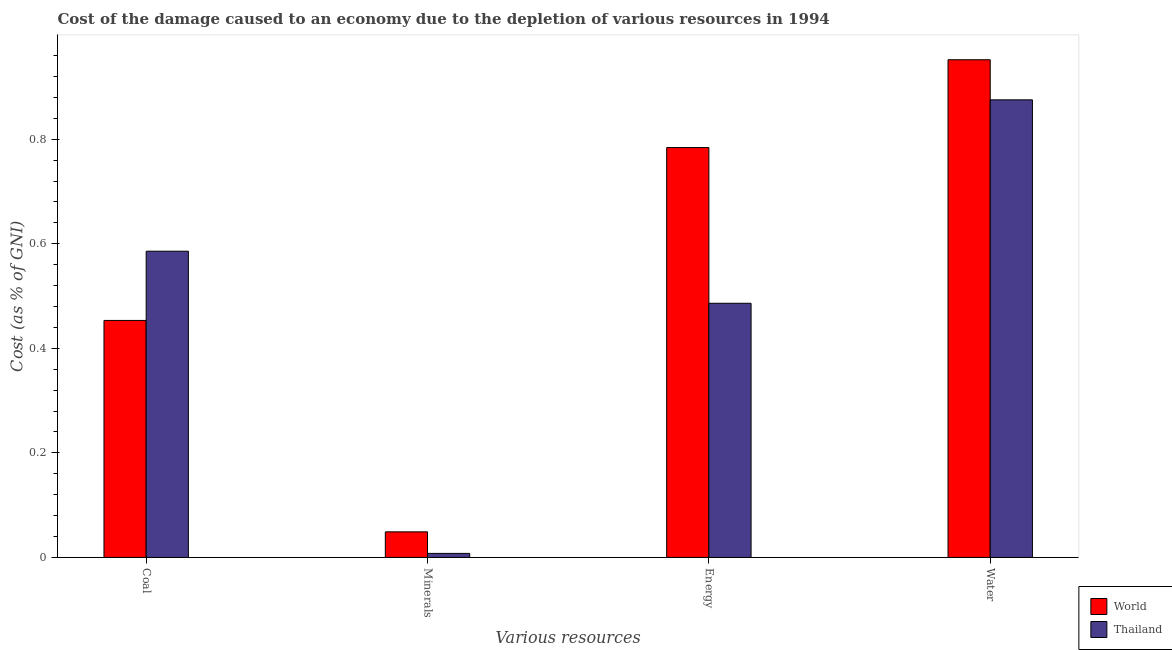How many different coloured bars are there?
Your response must be concise. 2. Are the number of bars per tick equal to the number of legend labels?
Offer a terse response. Yes. Are the number of bars on each tick of the X-axis equal?
Your response must be concise. Yes. What is the label of the 1st group of bars from the left?
Provide a short and direct response. Coal. What is the cost of damage due to depletion of coal in World?
Make the answer very short. 0.45. Across all countries, what is the maximum cost of damage due to depletion of minerals?
Offer a terse response. 0.05. Across all countries, what is the minimum cost of damage due to depletion of minerals?
Your answer should be compact. 0.01. In which country was the cost of damage due to depletion of water minimum?
Keep it short and to the point. Thailand. What is the total cost of damage due to depletion of water in the graph?
Ensure brevity in your answer.  1.83. What is the difference between the cost of damage due to depletion of coal in Thailand and that in World?
Your response must be concise. 0.13. What is the difference between the cost of damage due to depletion of water in World and the cost of damage due to depletion of energy in Thailand?
Your answer should be compact. 0.47. What is the average cost of damage due to depletion of coal per country?
Offer a very short reply. 0.52. What is the difference between the cost of damage due to depletion of energy and cost of damage due to depletion of coal in World?
Offer a terse response. 0.33. What is the ratio of the cost of damage due to depletion of energy in Thailand to that in World?
Offer a terse response. 0.62. Is the cost of damage due to depletion of minerals in World less than that in Thailand?
Your answer should be compact. No. Is the difference between the cost of damage due to depletion of energy in Thailand and World greater than the difference between the cost of damage due to depletion of water in Thailand and World?
Provide a succinct answer. No. What is the difference between the highest and the second highest cost of damage due to depletion of water?
Offer a terse response. 0.08. What is the difference between the highest and the lowest cost of damage due to depletion of water?
Your answer should be very brief. 0.08. Is the sum of the cost of damage due to depletion of coal in Thailand and World greater than the maximum cost of damage due to depletion of water across all countries?
Make the answer very short. Yes. What does the 2nd bar from the left in Coal represents?
Give a very brief answer. Thailand. What does the 1st bar from the right in Minerals represents?
Your answer should be compact. Thailand. Are all the bars in the graph horizontal?
Your response must be concise. No. How many legend labels are there?
Ensure brevity in your answer.  2. How are the legend labels stacked?
Offer a very short reply. Vertical. What is the title of the graph?
Offer a very short reply. Cost of the damage caused to an economy due to the depletion of various resources in 1994 . What is the label or title of the X-axis?
Ensure brevity in your answer.  Various resources. What is the label or title of the Y-axis?
Your answer should be compact. Cost (as % of GNI). What is the Cost (as % of GNI) of World in Coal?
Give a very brief answer. 0.45. What is the Cost (as % of GNI) of Thailand in Coal?
Keep it short and to the point. 0.59. What is the Cost (as % of GNI) in World in Minerals?
Keep it short and to the point. 0.05. What is the Cost (as % of GNI) of Thailand in Minerals?
Offer a terse response. 0.01. What is the Cost (as % of GNI) of World in Energy?
Offer a very short reply. 0.78. What is the Cost (as % of GNI) of Thailand in Energy?
Provide a succinct answer. 0.49. What is the Cost (as % of GNI) of World in Water?
Offer a very short reply. 0.95. What is the Cost (as % of GNI) of Thailand in Water?
Your response must be concise. 0.88. Across all Various resources, what is the maximum Cost (as % of GNI) in World?
Make the answer very short. 0.95. Across all Various resources, what is the maximum Cost (as % of GNI) of Thailand?
Your answer should be very brief. 0.88. Across all Various resources, what is the minimum Cost (as % of GNI) of World?
Your response must be concise. 0.05. Across all Various resources, what is the minimum Cost (as % of GNI) of Thailand?
Your answer should be compact. 0.01. What is the total Cost (as % of GNI) of World in the graph?
Provide a succinct answer. 2.24. What is the total Cost (as % of GNI) of Thailand in the graph?
Offer a terse response. 1.95. What is the difference between the Cost (as % of GNI) in World in Coal and that in Minerals?
Offer a very short reply. 0.4. What is the difference between the Cost (as % of GNI) of Thailand in Coal and that in Minerals?
Your response must be concise. 0.58. What is the difference between the Cost (as % of GNI) of World in Coal and that in Energy?
Offer a very short reply. -0.33. What is the difference between the Cost (as % of GNI) of Thailand in Coal and that in Energy?
Make the answer very short. 0.1. What is the difference between the Cost (as % of GNI) in World in Coal and that in Water?
Ensure brevity in your answer.  -0.5. What is the difference between the Cost (as % of GNI) in Thailand in Coal and that in Water?
Your answer should be compact. -0.29. What is the difference between the Cost (as % of GNI) of World in Minerals and that in Energy?
Keep it short and to the point. -0.74. What is the difference between the Cost (as % of GNI) of Thailand in Minerals and that in Energy?
Your answer should be compact. -0.48. What is the difference between the Cost (as % of GNI) of World in Minerals and that in Water?
Provide a short and direct response. -0.9. What is the difference between the Cost (as % of GNI) in Thailand in Minerals and that in Water?
Ensure brevity in your answer.  -0.87. What is the difference between the Cost (as % of GNI) in World in Energy and that in Water?
Offer a very short reply. -0.17. What is the difference between the Cost (as % of GNI) of Thailand in Energy and that in Water?
Keep it short and to the point. -0.39. What is the difference between the Cost (as % of GNI) in World in Coal and the Cost (as % of GNI) in Thailand in Minerals?
Your answer should be very brief. 0.45. What is the difference between the Cost (as % of GNI) in World in Coal and the Cost (as % of GNI) in Thailand in Energy?
Offer a terse response. -0.03. What is the difference between the Cost (as % of GNI) of World in Coal and the Cost (as % of GNI) of Thailand in Water?
Offer a very short reply. -0.42. What is the difference between the Cost (as % of GNI) of World in Minerals and the Cost (as % of GNI) of Thailand in Energy?
Make the answer very short. -0.44. What is the difference between the Cost (as % of GNI) of World in Minerals and the Cost (as % of GNI) of Thailand in Water?
Keep it short and to the point. -0.83. What is the difference between the Cost (as % of GNI) in World in Energy and the Cost (as % of GNI) in Thailand in Water?
Provide a succinct answer. -0.09. What is the average Cost (as % of GNI) in World per Various resources?
Keep it short and to the point. 0.56. What is the average Cost (as % of GNI) in Thailand per Various resources?
Your answer should be very brief. 0.49. What is the difference between the Cost (as % of GNI) in World and Cost (as % of GNI) in Thailand in Coal?
Make the answer very short. -0.13. What is the difference between the Cost (as % of GNI) of World and Cost (as % of GNI) of Thailand in Minerals?
Provide a short and direct response. 0.04. What is the difference between the Cost (as % of GNI) in World and Cost (as % of GNI) in Thailand in Energy?
Give a very brief answer. 0.3. What is the difference between the Cost (as % of GNI) of World and Cost (as % of GNI) of Thailand in Water?
Keep it short and to the point. 0.08. What is the ratio of the Cost (as % of GNI) in World in Coal to that in Minerals?
Provide a succinct answer. 9.27. What is the ratio of the Cost (as % of GNI) of Thailand in Coal to that in Minerals?
Your response must be concise. 76.13. What is the ratio of the Cost (as % of GNI) of World in Coal to that in Energy?
Provide a short and direct response. 0.58. What is the ratio of the Cost (as % of GNI) in Thailand in Coal to that in Energy?
Provide a succinct answer. 1.2. What is the ratio of the Cost (as % of GNI) of World in Coal to that in Water?
Give a very brief answer. 0.48. What is the ratio of the Cost (as % of GNI) in Thailand in Coal to that in Water?
Offer a very short reply. 0.67. What is the ratio of the Cost (as % of GNI) in World in Minerals to that in Energy?
Your answer should be compact. 0.06. What is the ratio of the Cost (as % of GNI) in Thailand in Minerals to that in Energy?
Offer a very short reply. 0.02. What is the ratio of the Cost (as % of GNI) in World in Minerals to that in Water?
Your response must be concise. 0.05. What is the ratio of the Cost (as % of GNI) in Thailand in Minerals to that in Water?
Make the answer very short. 0.01. What is the ratio of the Cost (as % of GNI) of World in Energy to that in Water?
Provide a short and direct response. 0.82. What is the ratio of the Cost (as % of GNI) in Thailand in Energy to that in Water?
Offer a very short reply. 0.56. What is the difference between the highest and the second highest Cost (as % of GNI) of World?
Ensure brevity in your answer.  0.17. What is the difference between the highest and the second highest Cost (as % of GNI) of Thailand?
Make the answer very short. 0.29. What is the difference between the highest and the lowest Cost (as % of GNI) in World?
Make the answer very short. 0.9. What is the difference between the highest and the lowest Cost (as % of GNI) in Thailand?
Your answer should be very brief. 0.87. 